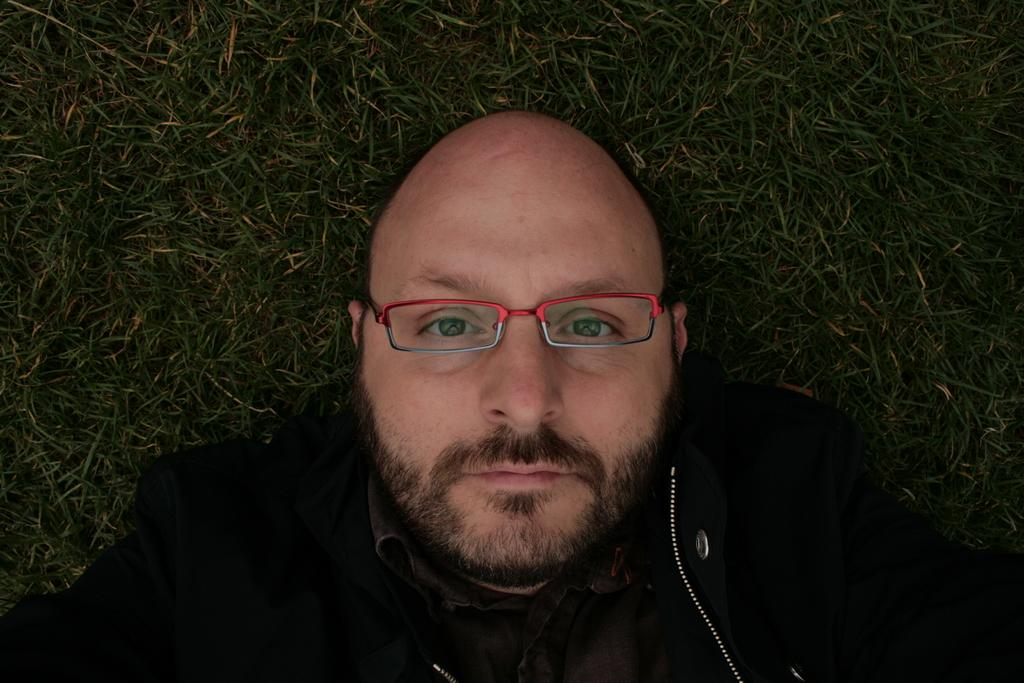Who is present in the image? There is a person in the image. What is the person wearing? The person is wearing a black jacket. What accessory is the person wearing? The person is wearing spectacles. Where is the person located in the image? The person is lying on the grass ground. What type of water can be seen flowing through the person's jacket in the image? There is no water flowing through the person's jacket in the image. 